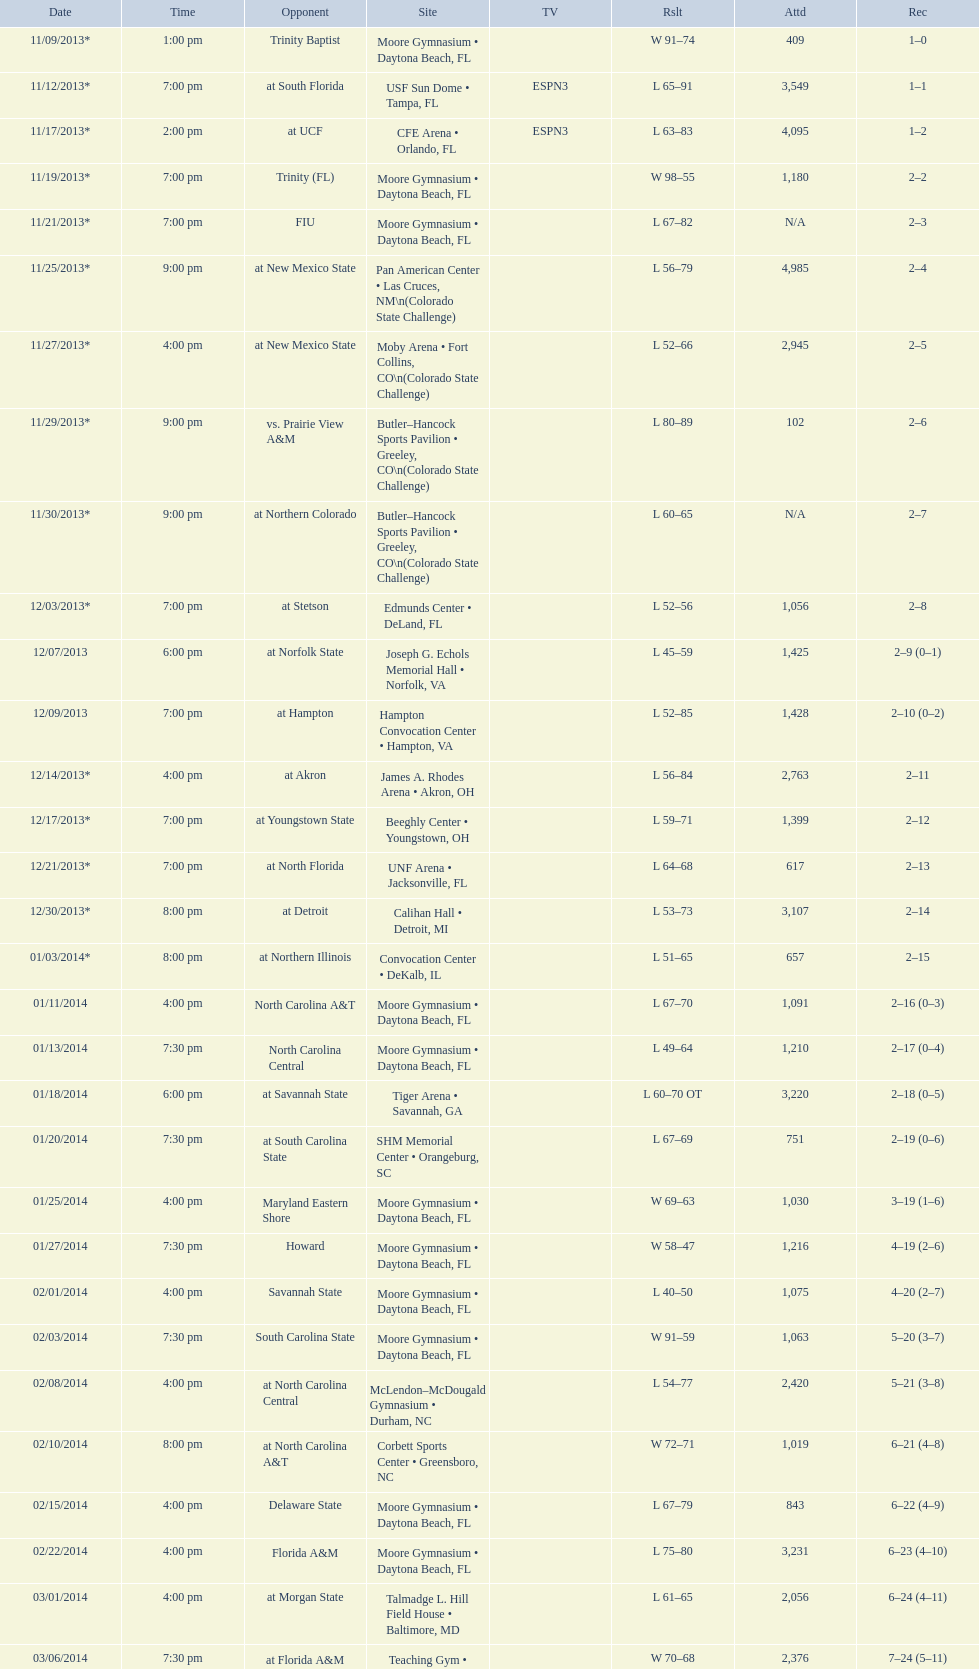I'm looking to parse the entire table for insights. Could you assist me with that? {'header': ['Date', 'Time', 'Opponent', 'Site', 'TV', 'Rslt', 'Attd', 'Rec'], 'rows': [['11/09/2013*', '1:00 pm', 'Trinity Baptist', 'Moore Gymnasium • Daytona Beach, FL', '', 'W\xa091–74', '409', '1–0'], ['11/12/2013*', '7:00 pm', 'at\xa0South Florida', 'USF Sun Dome • Tampa, FL', 'ESPN3', 'L\xa065–91', '3,549', '1–1'], ['11/17/2013*', '2:00 pm', 'at\xa0UCF', 'CFE Arena • Orlando, FL', 'ESPN3', 'L\xa063–83', '4,095', '1–2'], ['11/19/2013*', '7:00 pm', 'Trinity (FL)', 'Moore Gymnasium • Daytona Beach, FL', '', 'W\xa098–55', '1,180', '2–2'], ['11/21/2013*', '7:00 pm', 'FIU', 'Moore Gymnasium • Daytona Beach, FL', '', 'L\xa067–82', 'N/A', '2–3'], ['11/25/2013*', '9:00 pm', 'at\xa0New Mexico State', 'Pan American Center • Las Cruces, NM\\n(Colorado State Challenge)', '', 'L\xa056–79', '4,985', '2–4'], ['11/27/2013*', '4:00 pm', 'at\xa0New Mexico State', 'Moby Arena • Fort Collins, CO\\n(Colorado State Challenge)', '', 'L\xa052–66', '2,945', '2–5'], ['11/29/2013*', '9:00 pm', 'vs.\xa0Prairie View A&M', 'Butler–Hancock Sports Pavilion • Greeley, CO\\n(Colorado State Challenge)', '', 'L\xa080–89', '102', '2–6'], ['11/30/2013*', '9:00 pm', 'at\xa0Northern Colorado', 'Butler–Hancock Sports Pavilion • Greeley, CO\\n(Colorado State Challenge)', '', 'L\xa060–65', 'N/A', '2–7'], ['12/03/2013*', '7:00 pm', 'at\xa0Stetson', 'Edmunds Center • DeLand, FL', '', 'L\xa052–56', '1,056', '2–8'], ['12/07/2013', '6:00 pm', 'at\xa0Norfolk State', 'Joseph G. Echols Memorial Hall • Norfolk, VA', '', 'L\xa045–59', '1,425', '2–9 (0–1)'], ['12/09/2013', '7:00 pm', 'at\xa0Hampton', 'Hampton Convocation Center • Hampton, VA', '', 'L\xa052–85', '1,428', '2–10 (0–2)'], ['12/14/2013*', '4:00 pm', 'at\xa0Akron', 'James A. Rhodes Arena • Akron, OH', '', 'L\xa056–84', '2,763', '2–11'], ['12/17/2013*', '7:00 pm', 'at\xa0Youngstown State', 'Beeghly Center • Youngstown, OH', '', 'L\xa059–71', '1,399', '2–12'], ['12/21/2013*', '7:00 pm', 'at\xa0North Florida', 'UNF Arena • Jacksonville, FL', '', 'L\xa064–68', '617', '2–13'], ['12/30/2013*', '8:00 pm', 'at\xa0Detroit', 'Calihan Hall • Detroit, MI', '', 'L\xa053–73', '3,107', '2–14'], ['01/03/2014*', '8:00 pm', 'at\xa0Northern Illinois', 'Convocation Center • DeKalb, IL', '', 'L\xa051–65', '657', '2–15'], ['01/11/2014', '4:00 pm', 'North Carolina A&T', 'Moore Gymnasium • Daytona Beach, FL', '', 'L\xa067–70', '1,091', '2–16 (0–3)'], ['01/13/2014', '7:30 pm', 'North Carolina Central', 'Moore Gymnasium • Daytona Beach, FL', '', 'L\xa049–64', '1,210', '2–17 (0–4)'], ['01/18/2014', '6:00 pm', 'at\xa0Savannah State', 'Tiger Arena • Savannah, GA', '', 'L\xa060–70\xa0OT', '3,220', '2–18 (0–5)'], ['01/20/2014', '7:30 pm', 'at\xa0South Carolina State', 'SHM Memorial Center • Orangeburg, SC', '', 'L\xa067–69', '751', '2–19 (0–6)'], ['01/25/2014', '4:00 pm', 'Maryland Eastern Shore', 'Moore Gymnasium • Daytona Beach, FL', '', 'W\xa069–63', '1,030', '3–19 (1–6)'], ['01/27/2014', '7:30 pm', 'Howard', 'Moore Gymnasium • Daytona Beach, FL', '', 'W\xa058–47', '1,216', '4–19 (2–6)'], ['02/01/2014', '4:00 pm', 'Savannah State', 'Moore Gymnasium • Daytona Beach, FL', '', 'L\xa040–50', '1,075', '4–20 (2–7)'], ['02/03/2014', '7:30 pm', 'South Carolina State', 'Moore Gymnasium • Daytona Beach, FL', '', 'W\xa091–59', '1,063', '5–20 (3–7)'], ['02/08/2014', '4:00 pm', 'at\xa0North Carolina Central', 'McLendon–McDougald Gymnasium • Durham, NC', '', 'L\xa054–77', '2,420', '5–21 (3–8)'], ['02/10/2014', '8:00 pm', 'at\xa0North Carolina A&T', 'Corbett Sports Center • Greensboro, NC', '', 'W\xa072–71', '1,019', '6–21 (4–8)'], ['02/15/2014', '4:00 pm', 'Delaware State', 'Moore Gymnasium • Daytona Beach, FL', '', 'L\xa067–79', '843', '6–22 (4–9)'], ['02/22/2014', '4:00 pm', 'Florida A&M', 'Moore Gymnasium • Daytona Beach, FL', '', 'L\xa075–80', '3,231', '6–23 (4–10)'], ['03/01/2014', '4:00 pm', 'at\xa0Morgan State', 'Talmadge L. Hill Field House • Baltimore, MD', '', 'L\xa061–65', '2,056', '6–24 (4–11)'], ['03/06/2014', '7:30 pm', 'at\xa0Florida A&M', 'Teaching Gym • Tallahassee, FL', '', 'W\xa070–68', '2,376', '7–24 (5–11)'], ['03/11/2014', '6:30 pm', 'vs.\xa0Coppin State', 'Norfolk Scope • Norfolk, VA\\n(First round)', '', 'L\xa068–75', '4,658', '7–25']]} Was the attendance of the game held on 11/19/2013 greater than 1,000? Yes. 